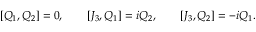Convert formula to latex. <formula><loc_0><loc_0><loc_500><loc_500>[ Q _ { 1 } , Q _ { 2 } ] = 0 , \quad [ J _ { 3 } , Q _ { 1 } ] = i Q _ { 2 } , \quad [ J _ { 3 } , Q _ { 2 } ] = - i Q _ { 1 } .</formula> 